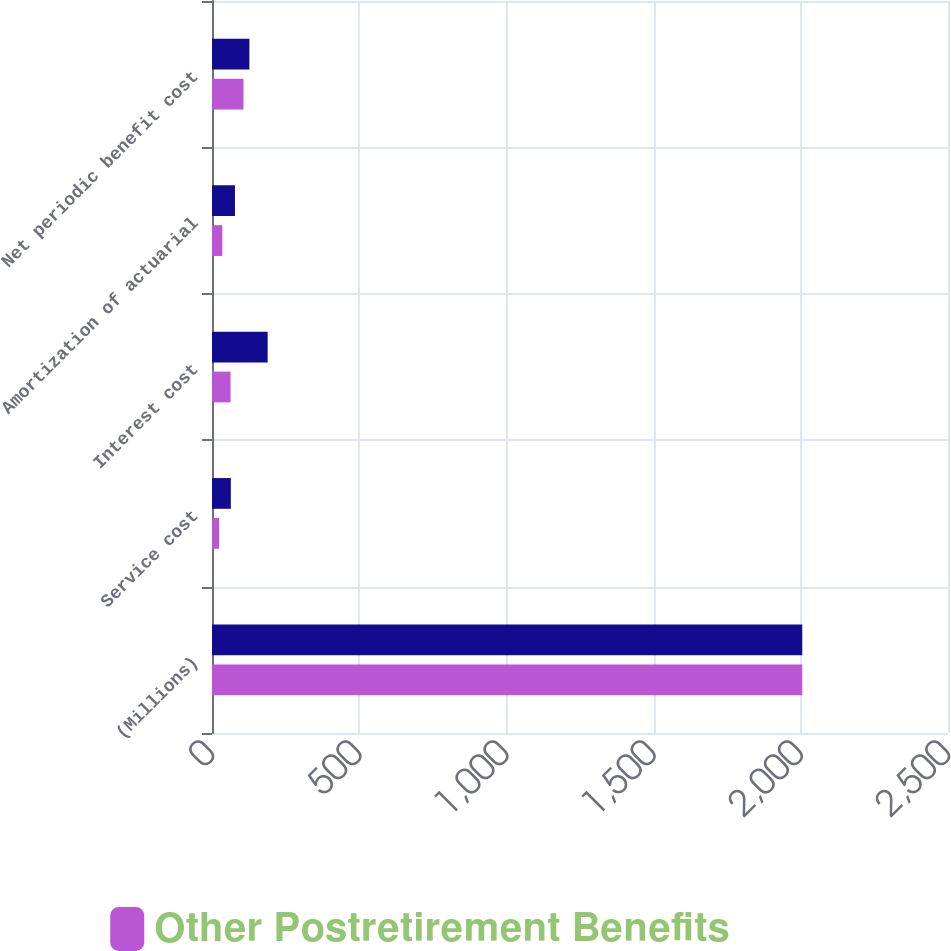Convert chart. <chart><loc_0><loc_0><loc_500><loc_500><stacked_bar_chart><ecel><fcel>(Millions)<fcel>Service cost<fcel>Interest cost<fcel>Amortization of actuarial<fcel>Net periodic benefit cost<nl><fcel>nan<fcel>2005<fcel>64<fcel>189<fcel>78<fcel>127<nl><fcel>Other Postretirement Benefits<fcel>2005<fcel>24<fcel>63<fcel>35<fcel>107<nl></chart> 